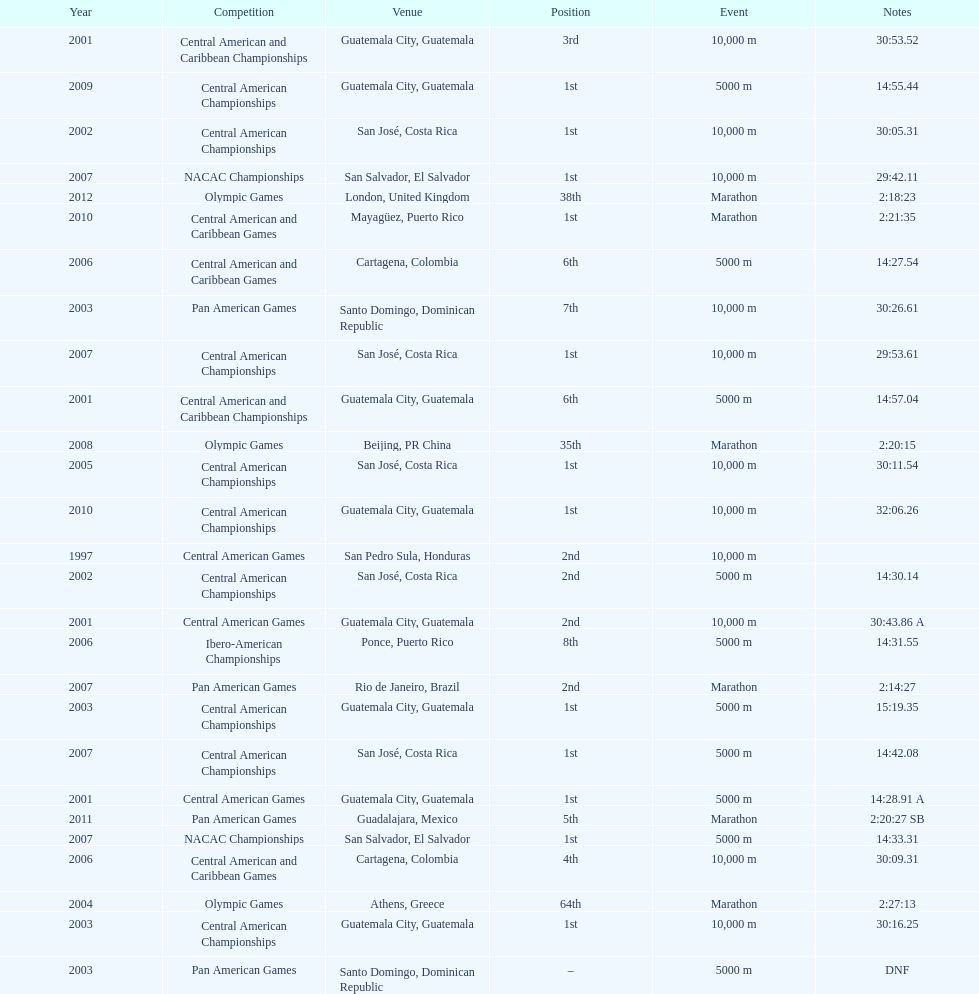How many times has the position of 1st been achieved? 12. 